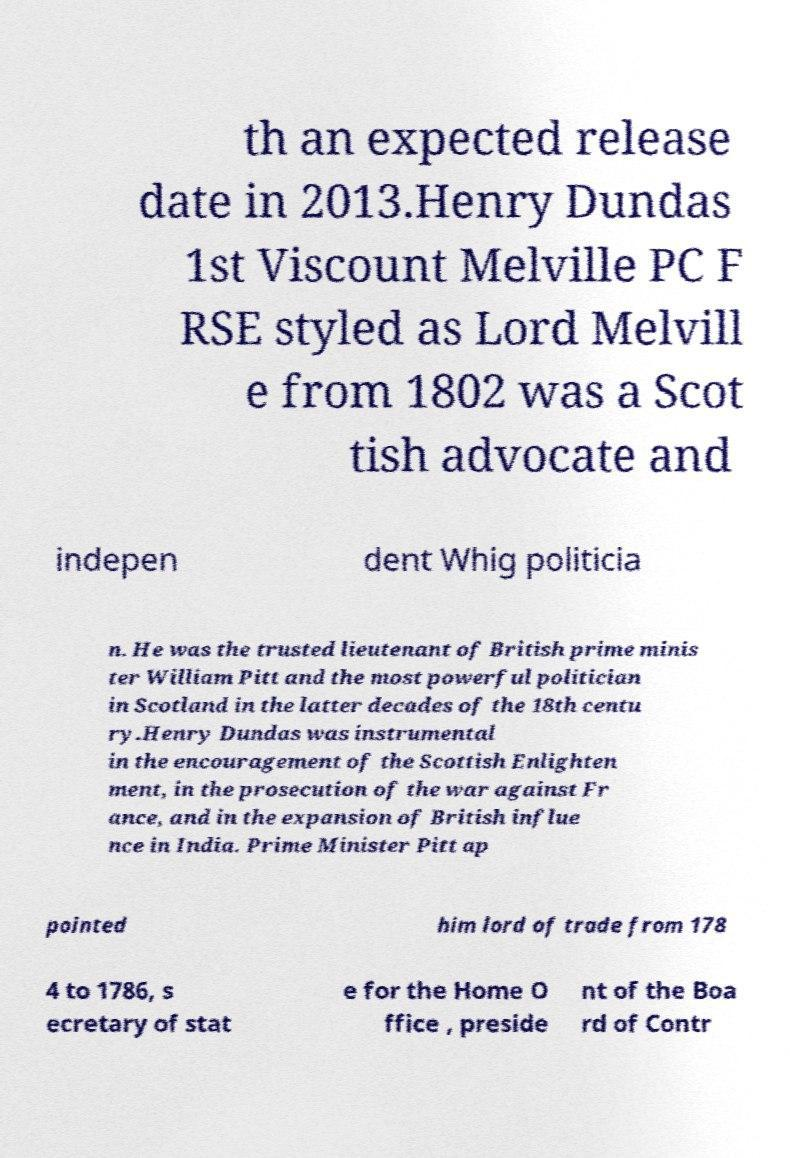Can you read and provide the text displayed in the image?This photo seems to have some interesting text. Can you extract and type it out for me? th an expected release date in 2013.Henry Dundas 1st Viscount Melville PC F RSE styled as Lord Melvill e from 1802 was a Scot tish advocate and indepen dent Whig politicia n. He was the trusted lieutenant of British prime minis ter William Pitt and the most powerful politician in Scotland in the latter decades of the 18th centu ry.Henry Dundas was instrumental in the encouragement of the Scottish Enlighten ment, in the prosecution of the war against Fr ance, and in the expansion of British influe nce in India. Prime Minister Pitt ap pointed him lord of trade from 178 4 to 1786, s ecretary of stat e for the Home O ffice , preside nt of the Boa rd of Contr 